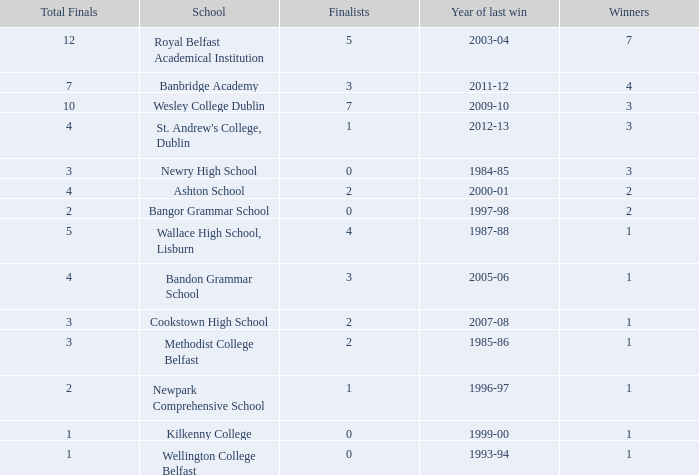What is the name of the school where the year of last win is 1985-86? Methodist College Belfast. 